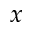<formula> <loc_0><loc_0><loc_500><loc_500>x</formula> 